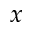<formula> <loc_0><loc_0><loc_500><loc_500>x</formula> 